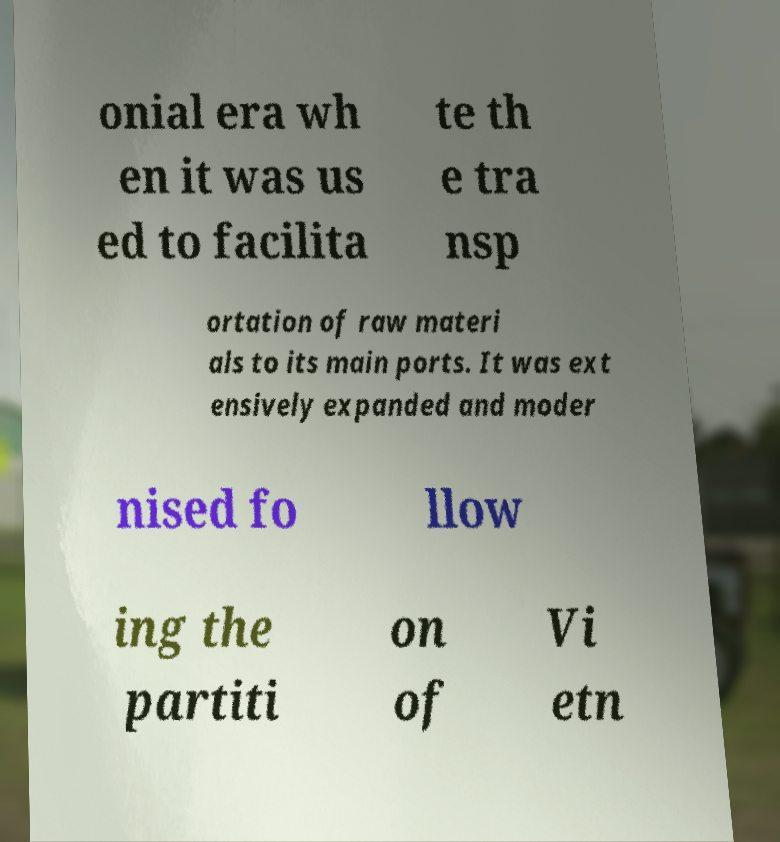Could you assist in decoding the text presented in this image and type it out clearly? onial era wh en it was us ed to facilita te th e tra nsp ortation of raw materi als to its main ports. It was ext ensively expanded and moder nised fo llow ing the partiti on of Vi etn 